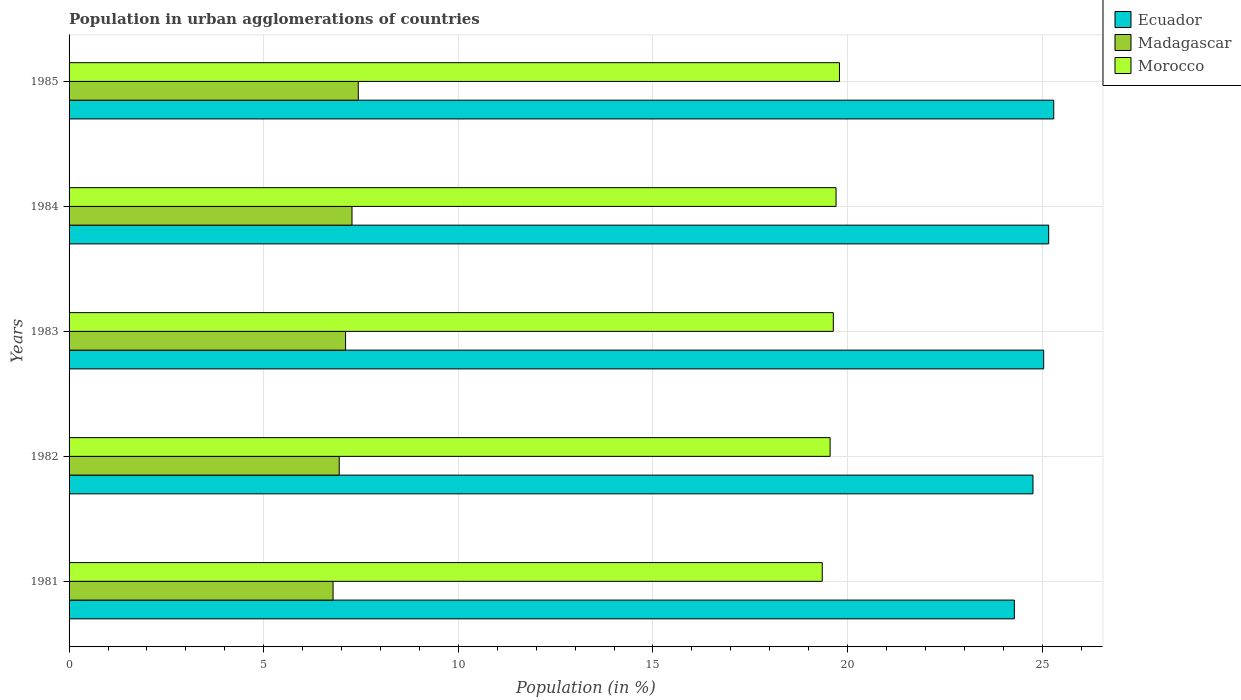How many different coloured bars are there?
Your answer should be compact. 3. How many bars are there on the 1st tick from the top?
Offer a very short reply. 3. How many bars are there on the 2nd tick from the bottom?
Your answer should be very brief. 3. What is the label of the 1st group of bars from the top?
Provide a short and direct response. 1985. In how many cases, is the number of bars for a given year not equal to the number of legend labels?
Provide a succinct answer. 0. What is the percentage of population in urban agglomerations in Madagascar in 1982?
Offer a terse response. 6.94. Across all years, what is the maximum percentage of population in urban agglomerations in Madagascar?
Provide a short and direct response. 7.43. Across all years, what is the minimum percentage of population in urban agglomerations in Morocco?
Make the answer very short. 19.35. What is the total percentage of population in urban agglomerations in Ecuador in the graph?
Your answer should be compact. 124.54. What is the difference between the percentage of population in urban agglomerations in Morocco in 1984 and that in 1985?
Your answer should be compact. -0.09. What is the difference between the percentage of population in urban agglomerations in Morocco in 1981 and the percentage of population in urban agglomerations in Madagascar in 1984?
Provide a succinct answer. 12.08. What is the average percentage of population in urban agglomerations in Morocco per year?
Your response must be concise. 19.6. In the year 1981, what is the difference between the percentage of population in urban agglomerations in Ecuador and percentage of population in urban agglomerations in Morocco?
Give a very brief answer. 4.93. What is the ratio of the percentage of population in urban agglomerations in Morocco in 1984 to that in 1985?
Provide a succinct answer. 1. Is the percentage of population in urban agglomerations in Madagascar in 1981 less than that in 1983?
Provide a short and direct response. Yes. What is the difference between the highest and the second highest percentage of population in urban agglomerations in Madagascar?
Keep it short and to the point. 0.16. What is the difference between the highest and the lowest percentage of population in urban agglomerations in Ecuador?
Your answer should be very brief. 1.01. In how many years, is the percentage of population in urban agglomerations in Ecuador greater than the average percentage of population in urban agglomerations in Ecuador taken over all years?
Your answer should be compact. 3. Is the sum of the percentage of population in urban agglomerations in Ecuador in 1983 and 1984 greater than the maximum percentage of population in urban agglomerations in Morocco across all years?
Your answer should be very brief. Yes. What does the 2nd bar from the top in 1981 represents?
Your response must be concise. Madagascar. What does the 1st bar from the bottom in 1982 represents?
Your answer should be compact. Ecuador. Are all the bars in the graph horizontal?
Ensure brevity in your answer.  Yes. What is the difference between two consecutive major ticks on the X-axis?
Offer a very short reply. 5. Are the values on the major ticks of X-axis written in scientific E-notation?
Keep it short and to the point. No. Does the graph contain any zero values?
Your answer should be very brief. No. Does the graph contain grids?
Your answer should be compact. Yes. Where does the legend appear in the graph?
Give a very brief answer. Top right. What is the title of the graph?
Offer a very short reply. Population in urban agglomerations of countries. Does "Bhutan" appear as one of the legend labels in the graph?
Your response must be concise. No. What is the Population (in %) of Ecuador in 1981?
Make the answer very short. 24.28. What is the Population (in %) of Madagascar in 1981?
Ensure brevity in your answer.  6.78. What is the Population (in %) of Morocco in 1981?
Give a very brief answer. 19.35. What is the Population (in %) in Ecuador in 1982?
Give a very brief answer. 24.76. What is the Population (in %) in Madagascar in 1982?
Offer a very short reply. 6.94. What is the Population (in %) of Morocco in 1982?
Give a very brief answer. 19.55. What is the Population (in %) of Ecuador in 1983?
Offer a very short reply. 25.04. What is the Population (in %) of Madagascar in 1983?
Your response must be concise. 7.1. What is the Population (in %) in Morocco in 1983?
Ensure brevity in your answer.  19.63. What is the Population (in %) of Ecuador in 1984?
Offer a terse response. 25.17. What is the Population (in %) of Madagascar in 1984?
Provide a short and direct response. 7.27. What is the Population (in %) in Morocco in 1984?
Offer a terse response. 19.7. What is the Population (in %) of Ecuador in 1985?
Provide a short and direct response. 25.29. What is the Population (in %) in Madagascar in 1985?
Your answer should be compact. 7.43. What is the Population (in %) of Morocco in 1985?
Make the answer very short. 19.79. Across all years, what is the maximum Population (in %) of Ecuador?
Your answer should be compact. 25.29. Across all years, what is the maximum Population (in %) of Madagascar?
Provide a succinct answer. 7.43. Across all years, what is the maximum Population (in %) in Morocco?
Make the answer very short. 19.79. Across all years, what is the minimum Population (in %) in Ecuador?
Provide a short and direct response. 24.28. Across all years, what is the minimum Population (in %) of Madagascar?
Give a very brief answer. 6.78. Across all years, what is the minimum Population (in %) of Morocco?
Your answer should be compact. 19.35. What is the total Population (in %) in Ecuador in the graph?
Give a very brief answer. 124.54. What is the total Population (in %) of Madagascar in the graph?
Your response must be concise. 35.52. What is the total Population (in %) in Morocco in the graph?
Ensure brevity in your answer.  98.02. What is the difference between the Population (in %) in Ecuador in 1981 and that in 1982?
Ensure brevity in your answer.  -0.48. What is the difference between the Population (in %) in Madagascar in 1981 and that in 1982?
Offer a terse response. -0.16. What is the difference between the Population (in %) of Morocco in 1981 and that in 1982?
Offer a very short reply. -0.2. What is the difference between the Population (in %) in Ecuador in 1981 and that in 1983?
Give a very brief answer. -0.75. What is the difference between the Population (in %) in Madagascar in 1981 and that in 1983?
Keep it short and to the point. -0.32. What is the difference between the Population (in %) in Morocco in 1981 and that in 1983?
Make the answer very short. -0.28. What is the difference between the Population (in %) of Ecuador in 1981 and that in 1984?
Your response must be concise. -0.88. What is the difference between the Population (in %) of Madagascar in 1981 and that in 1984?
Your answer should be compact. -0.49. What is the difference between the Population (in %) in Morocco in 1981 and that in 1984?
Offer a terse response. -0.35. What is the difference between the Population (in %) in Ecuador in 1981 and that in 1985?
Your answer should be very brief. -1.01. What is the difference between the Population (in %) of Madagascar in 1981 and that in 1985?
Your answer should be compact. -0.65. What is the difference between the Population (in %) in Morocco in 1981 and that in 1985?
Give a very brief answer. -0.44. What is the difference between the Population (in %) of Ecuador in 1982 and that in 1983?
Keep it short and to the point. -0.27. What is the difference between the Population (in %) of Madagascar in 1982 and that in 1983?
Offer a very short reply. -0.16. What is the difference between the Population (in %) in Morocco in 1982 and that in 1983?
Keep it short and to the point. -0.08. What is the difference between the Population (in %) of Ecuador in 1982 and that in 1984?
Offer a terse response. -0.4. What is the difference between the Population (in %) of Madagascar in 1982 and that in 1984?
Offer a very short reply. -0.33. What is the difference between the Population (in %) of Morocco in 1982 and that in 1984?
Make the answer very short. -0.15. What is the difference between the Population (in %) in Ecuador in 1982 and that in 1985?
Offer a terse response. -0.53. What is the difference between the Population (in %) of Madagascar in 1982 and that in 1985?
Ensure brevity in your answer.  -0.49. What is the difference between the Population (in %) in Morocco in 1982 and that in 1985?
Provide a short and direct response. -0.24. What is the difference between the Population (in %) of Ecuador in 1983 and that in 1984?
Provide a succinct answer. -0.13. What is the difference between the Population (in %) of Madagascar in 1983 and that in 1984?
Your answer should be compact. -0.16. What is the difference between the Population (in %) of Morocco in 1983 and that in 1984?
Your answer should be very brief. -0.07. What is the difference between the Population (in %) of Ecuador in 1983 and that in 1985?
Ensure brevity in your answer.  -0.26. What is the difference between the Population (in %) in Madagascar in 1983 and that in 1985?
Provide a short and direct response. -0.33. What is the difference between the Population (in %) in Morocco in 1983 and that in 1985?
Offer a terse response. -0.16. What is the difference between the Population (in %) in Ecuador in 1984 and that in 1985?
Offer a terse response. -0.13. What is the difference between the Population (in %) of Madagascar in 1984 and that in 1985?
Make the answer very short. -0.16. What is the difference between the Population (in %) in Morocco in 1984 and that in 1985?
Ensure brevity in your answer.  -0.09. What is the difference between the Population (in %) in Ecuador in 1981 and the Population (in %) in Madagascar in 1982?
Give a very brief answer. 17.34. What is the difference between the Population (in %) in Ecuador in 1981 and the Population (in %) in Morocco in 1982?
Offer a very short reply. 4.73. What is the difference between the Population (in %) in Madagascar in 1981 and the Population (in %) in Morocco in 1982?
Offer a terse response. -12.77. What is the difference between the Population (in %) in Ecuador in 1981 and the Population (in %) in Madagascar in 1983?
Make the answer very short. 17.18. What is the difference between the Population (in %) in Ecuador in 1981 and the Population (in %) in Morocco in 1983?
Ensure brevity in your answer.  4.65. What is the difference between the Population (in %) in Madagascar in 1981 and the Population (in %) in Morocco in 1983?
Provide a short and direct response. -12.85. What is the difference between the Population (in %) of Ecuador in 1981 and the Population (in %) of Madagascar in 1984?
Provide a short and direct response. 17.01. What is the difference between the Population (in %) in Ecuador in 1981 and the Population (in %) in Morocco in 1984?
Offer a very short reply. 4.58. What is the difference between the Population (in %) in Madagascar in 1981 and the Population (in %) in Morocco in 1984?
Offer a terse response. -12.92. What is the difference between the Population (in %) of Ecuador in 1981 and the Population (in %) of Madagascar in 1985?
Provide a short and direct response. 16.85. What is the difference between the Population (in %) of Ecuador in 1981 and the Population (in %) of Morocco in 1985?
Make the answer very short. 4.49. What is the difference between the Population (in %) in Madagascar in 1981 and the Population (in %) in Morocco in 1985?
Your answer should be compact. -13.01. What is the difference between the Population (in %) in Ecuador in 1982 and the Population (in %) in Madagascar in 1983?
Your response must be concise. 17.66. What is the difference between the Population (in %) in Ecuador in 1982 and the Population (in %) in Morocco in 1983?
Offer a terse response. 5.13. What is the difference between the Population (in %) in Madagascar in 1982 and the Population (in %) in Morocco in 1983?
Make the answer very short. -12.69. What is the difference between the Population (in %) of Ecuador in 1982 and the Population (in %) of Madagascar in 1984?
Give a very brief answer. 17.49. What is the difference between the Population (in %) in Ecuador in 1982 and the Population (in %) in Morocco in 1984?
Your answer should be compact. 5.06. What is the difference between the Population (in %) in Madagascar in 1982 and the Population (in %) in Morocco in 1984?
Make the answer very short. -12.76. What is the difference between the Population (in %) of Ecuador in 1982 and the Population (in %) of Madagascar in 1985?
Keep it short and to the point. 17.33. What is the difference between the Population (in %) in Ecuador in 1982 and the Population (in %) in Morocco in 1985?
Make the answer very short. 4.97. What is the difference between the Population (in %) in Madagascar in 1982 and the Population (in %) in Morocco in 1985?
Ensure brevity in your answer.  -12.85. What is the difference between the Population (in %) of Ecuador in 1983 and the Population (in %) of Madagascar in 1984?
Ensure brevity in your answer.  17.77. What is the difference between the Population (in %) of Ecuador in 1983 and the Population (in %) of Morocco in 1984?
Keep it short and to the point. 5.33. What is the difference between the Population (in %) of Madagascar in 1983 and the Population (in %) of Morocco in 1984?
Your answer should be very brief. -12.6. What is the difference between the Population (in %) of Ecuador in 1983 and the Population (in %) of Madagascar in 1985?
Your answer should be compact. 17.61. What is the difference between the Population (in %) of Ecuador in 1983 and the Population (in %) of Morocco in 1985?
Provide a succinct answer. 5.25. What is the difference between the Population (in %) in Madagascar in 1983 and the Population (in %) in Morocco in 1985?
Your response must be concise. -12.69. What is the difference between the Population (in %) in Ecuador in 1984 and the Population (in %) in Madagascar in 1985?
Your answer should be very brief. 17.74. What is the difference between the Population (in %) in Ecuador in 1984 and the Population (in %) in Morocco in 1985?
Provide a succinct answer. 5.37. What is the difference between the Population (in %) in Madagascar in 1984 and the Population (in %) in Morocco in 1985?
Provide a short and direct response. -12.52. What is the average Population (in %) of Ecuador per year?
Provide a short and direct response. 24.91. What is the average Population (in %) of Madagascar per year?
Your response must be concise. 7.1. What is the average Population (in %) in Morocco per year?
Provide a short and direct response. 19.6. In the year 1981, what is the difference between the Population (in %) in Ecuador and Population (in %) in Madagascar?
Your answer should be compact. 17.5. In the year 1981, what is the difference between the Population (in %) of Ecuador and Population (in %) of Morocco?
Give a very brief answer. 4.93. In the year 1981, what is the difference between the Population (in %) of Madagascar and Population (in %) of Morocco?
Give a very brief answer. -12.57. In the year 1982, what is the difference between the Population (in %) in Ecuador and Population (in %) in Madagascar?
Give a very brief answer. 17.82. In the year 1982, what is the difference between the Population (in %) in Ecuador and Population (in %) in Morocco?
Provide a short and direct response. 5.21. In the year 1982, what is the difference between the Population (in %) of Madagascar and Population (in %) of Morocco?
Offer a very short reply. -12.61. In the year 1983, what is the difference between the Population (in %) of Ecuador and Population (in %) of Madagascar?
Your response must be concise. 17.93. In the year 1983, what is the difference between the Population (in %) in Ecuador and Population (in %) in Morocco?
Make the answer very short. 5.4. In the year 1983, what is the difference between the Population (in %) of Madagascar and Population (in %) of Morocco?
Your answer should be very brief. -12.53. In the year 1984, what is the difference between the Population (in %) in Ecuador and Population (in %) in Madagascar?
Give a very brief answer. 17.9. In the year 1984, what is the difference between the Population (in %) of Ecuador and Population (in %) of Morocco?
Provide a succinct answer. 5.46. In the year 1984, what is the difference between the Population (in %) of Madagascar and Population (in %) of Morocco?
Offer a very short reply. -12.43. In the year 1985, what is the difference between the Population (in %) in Ecuador and Population (in %) in Madagascar?
Give a very brief answer. 17.87. In the year 1985, what is the difference between the Population (in %) of Ecuador and Population (in %) of Morocco?
Offer a very short reply. 5.5. In the year 1985, what is the difference between the Population (in %) in Madagascar and Population (in %) in Morocco?
Your response must be concise. -12.36. What is the ratio of the Population (in %) of Ecuador in 1981 to that in 1982?
Ensure brevity in your answer.  0.98. What is the ratio of the Population (in %) of Madagascar in 1981 to that in 1982?
Keep it short and to the point. 0.98. What is the ratio of the Population (in %) in Morocco in 1981 to that in 1982?
Ensure brevity in your answer.  0.99. What is the ratio of the Population (in %) in Ecuador in 1981 to that in 1983?
Give a very brief answer. 0.97. What is the ratio of the Population (in %) in Madagascar in 1981 to that in 1983?
Offer a terse response. 0.95. What is the ratio of the Population (in %) of Morocco in 1981 to that in 1983?
Offer a very short reply. 0.99. What is the ratio of the Population (in %) in Ecuador in 1981 to that in 1984?
Make the answer very short. 0.96. What is the ratio of the Population (in %) in Madagascar in 1981 to that in 1984?
Your answer should be very brief. 0.93. What is the ratio of the Population (in %) in Morocco in 1981 to that in 1984?
Your answer should be very brief. 0.98. What is the ratio of the Population (in %) of Madagascar in 1981 to that in 1985?
Make the answer very short. 0.91. What is the ratio of the Population (in %) in Morocco in 1981 to that in 1985?
Your answer should be very brief. 0.98. What is the ratio of the Population (in %) in Morocco in 1982 to that in 1983?
Offer a very short reply. 1. What is the ratio of the Population (in %) in Madagascar in 1982 to that in 1984?
Your answer should be very brief. 0.95. What is the ratio of the Population (in %) of Morocco in 1982 to that in 1984?
Offer a very short reply. 0.99. What is the ratio of the Population (in %) in Ecuador in 1982 to that in 1985?
Your answer should be compact. 0.98. What is the ratio of the Population (in %) of Madagascar in 1982 to that in 1985?
Make the answer very short. 0.93. What is the ratio of the Population (in %) in Morocco in 1982 to that in 1985?
Make the answer very short. 0.99. What is the ratio of the Population (in %) in Ecuador in 1983 to that in 1984?
Keep it short and to the point. 0.99. What is the ratio of the Population (in %) of Madagascar in 1983 to that in 1984?
Offer a terse response. 0.98. What is the ratio of the Population (in %) of Madagascar in 1983 to that in 1985?
Give a very brief answer. 0.96. What is the ratio of the Population (in %) of Morocco in 1983 to that in 1985?
Provide a short and direct response. 0.99. What is the ratio of the Population (in %) in Madagascar in 1984 to that in 1985?
Your response must be concise. 0.98. What is the difference between the highest and the second highest Population (in %) in Ecuador?
Keep it short and to the point. 0.13. What is the difference between the highest and the second highest Population (in %) of Madagascar?
Ensure brevity in your answer.  0.16. What is the difference between the highest and the second highest Population (in %) of Morocco?
Provide a short and direct response. 0.09. What is the difference between the highest and the lowest Population (in %) in Ecuador?
Offer a terse response. 1.01. What is the difference between the highest and the lowest Population (in %) of Madagascar?
Provide a succinct answer. 0.65. What is the difference between the highest and the lowest Population (in %) of Morocco?
Offer a terse response. 0.44. 